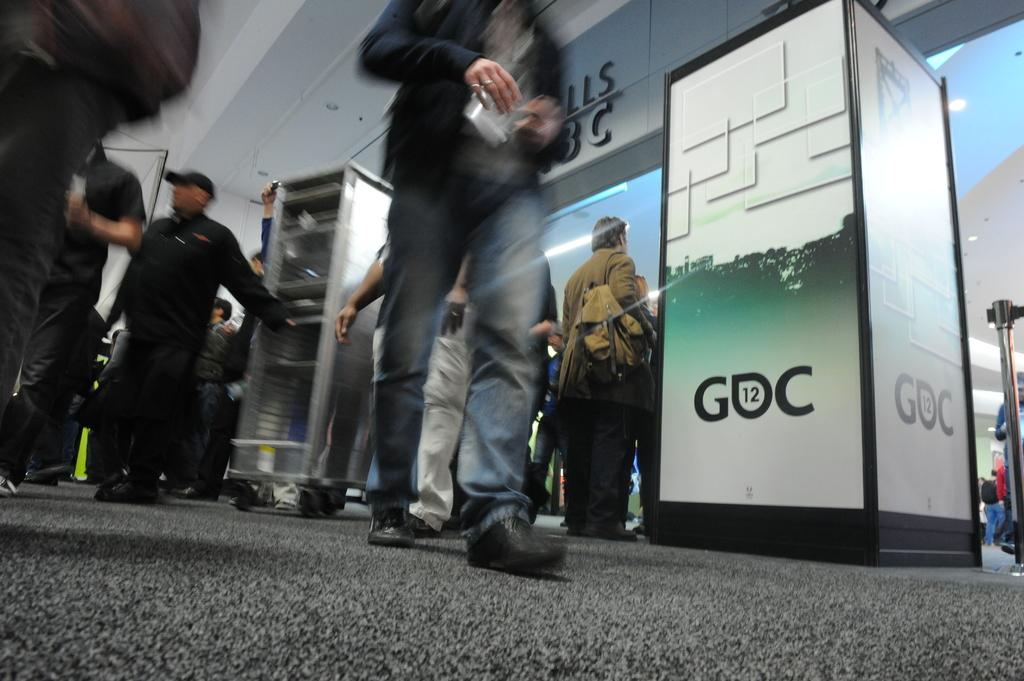What can be seen in the image regarding the people? There are persons wearing clothes in the image. What is located in the middle of the image? There is a rack in the middle of the image. What is present on the right side of the image? There is a barricade on the right side of the image. Can you tell me who is sitting on the throne in the image? There is no throne present in the image. What type of event is taking place in the image? The image does not depict any specific event; it only shows persons wearing clothes, a rack, and a barricade. 